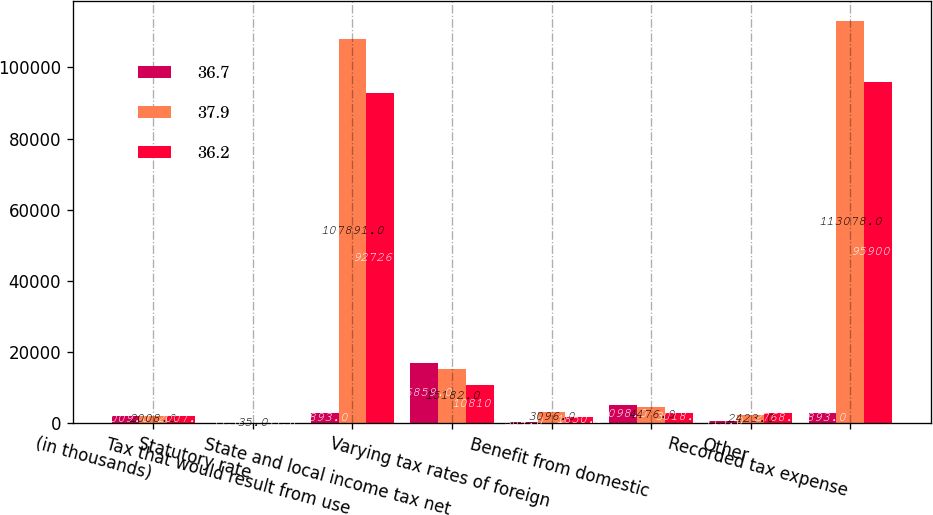Convert chart. <chart><loc_0><loc_0><loc_500><loc_500><stacked_bar_chart><ecel><fcel>(in thousands)<fcel>Statutory rate<fcel>Tax that would result from use<fcel>State and local income tax net<fcel>Varying tax rates of foreign<fcel>Benefit from domestic<fcel>Other<fcel>Recorded tax expense<nl><fcel>36.7<fcel>2009<fcel>35<fcel>2893<fcel>16859<fcel>384<fcel>5098<fcel>713<fcel>2893<nl><fcel>37.9<fcel>2008<fcel>35<fcel>107891<fcel>15182<fcel>3096<fcel>4476<fcel>2423<fcel>113078<nl><fcel>36.2<fcel>2007<fcel>35<fcel>92726<fcel>10810<fcel>1850<fcel>3018<fcel>2768<fcel>95900<nl></chart> 